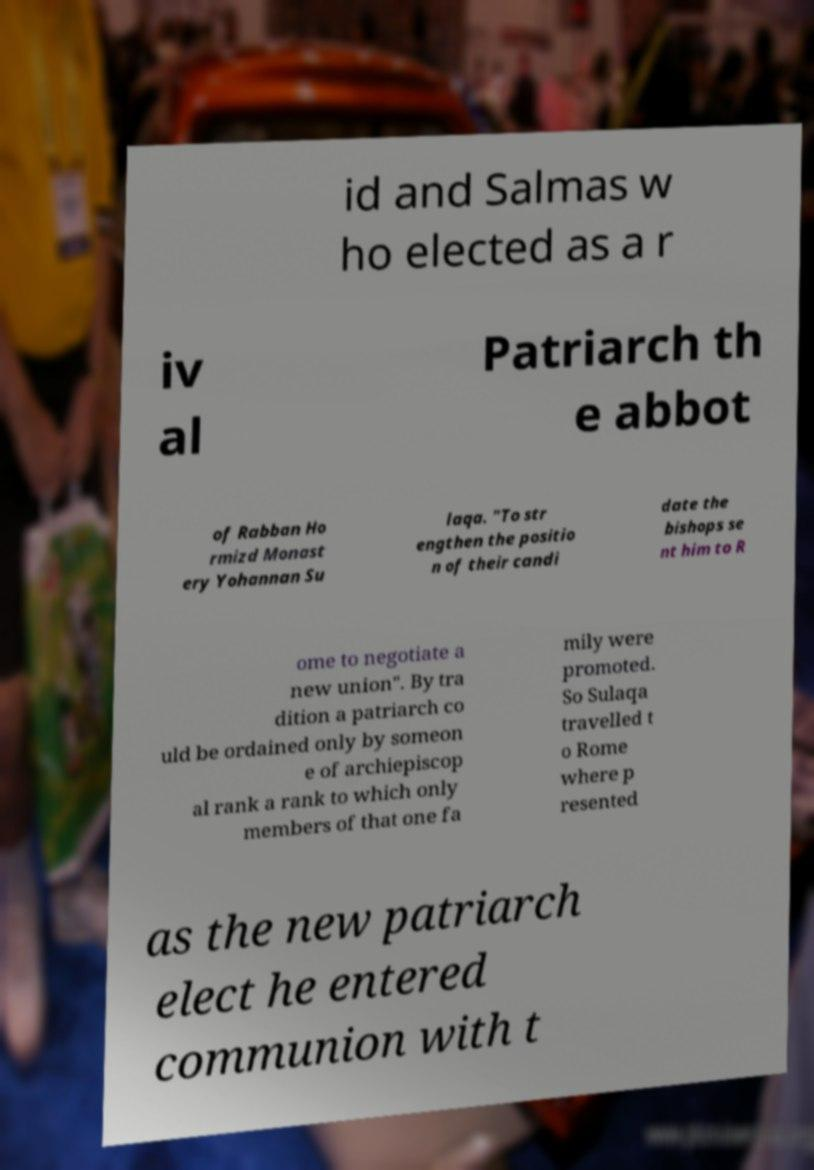There's text embedded in this image that I need extracted. Can you transcribe it verbatim? id and Salmas w ho elected as a r iv al Patriarch th e abbot of Rabban Ho rmizd Monast ery Yohannan Su laqa. "To str engthen the positio n of their candi date the bishops se nt him to R ome to negotiate a new union". By tra dition a patriarch co uld be ordained only by someon e of archiepiscop al rank a rank to which only members of that one fa mily were promoted. So Sulaqa travelled t o Rome where p resented as the new patriarch elect he entered communion with t 